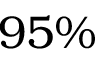<formula> <loc_0><loc_0><loc_500><loc_500>9 5 \%</formula> 